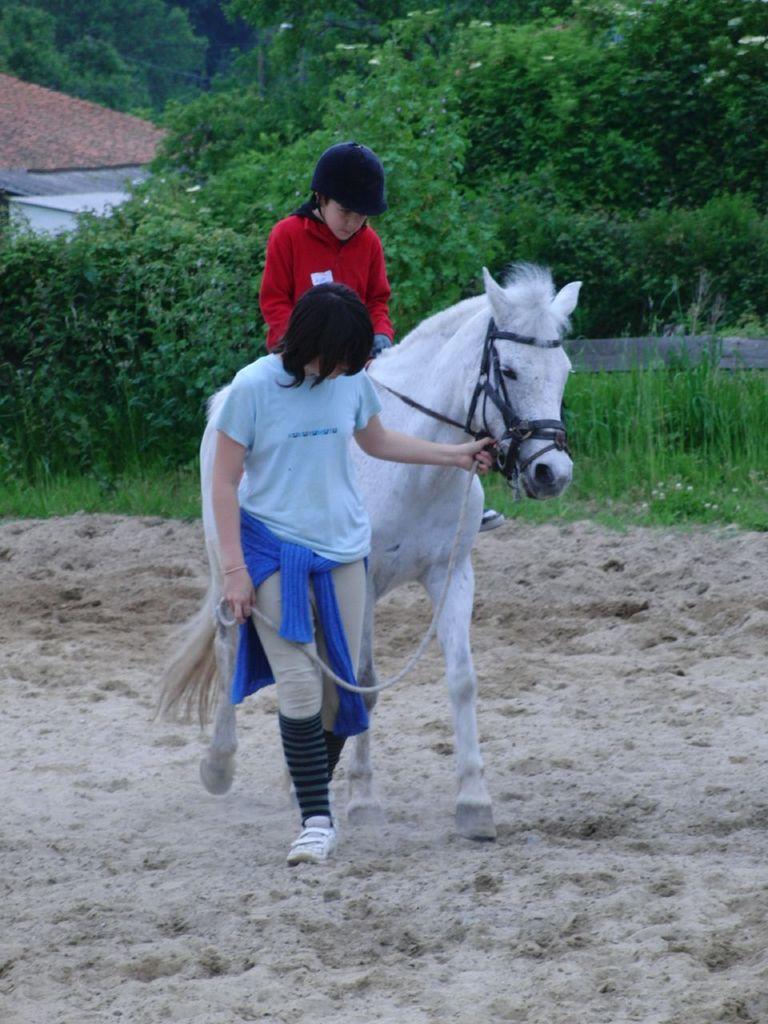In one or two sentences, can you explain what this image depicts? There is a white horse and a kid is sitting on the horse and a woman is carrying the horse forward by holding chain around its mouth and in the background there are a lot of trees and grass. 